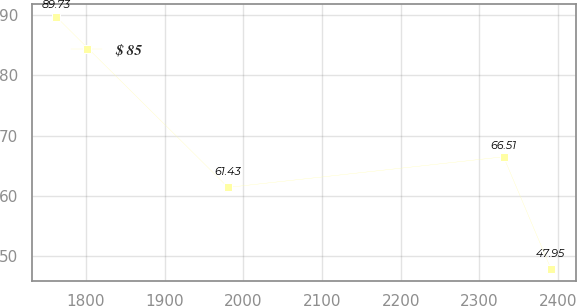Convert chart. <chart><loc_0><loc_0><loc_500><loc_500><line_chart><ecel><fcel>$ 85<nl><fcel>1762.15<fcel>89.73<nl><fcel>1980.52<fcel>61.43<nl><fcel>2330.82<fcel>66.51<nl><fcel>2390.95<fcel>47.95<nl></chart> 